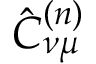<formula> <loc_0><loc_0><loc_500><loc_500>\hat { C } _ { \nu \mu } ^ { ( n ) }</formula> 